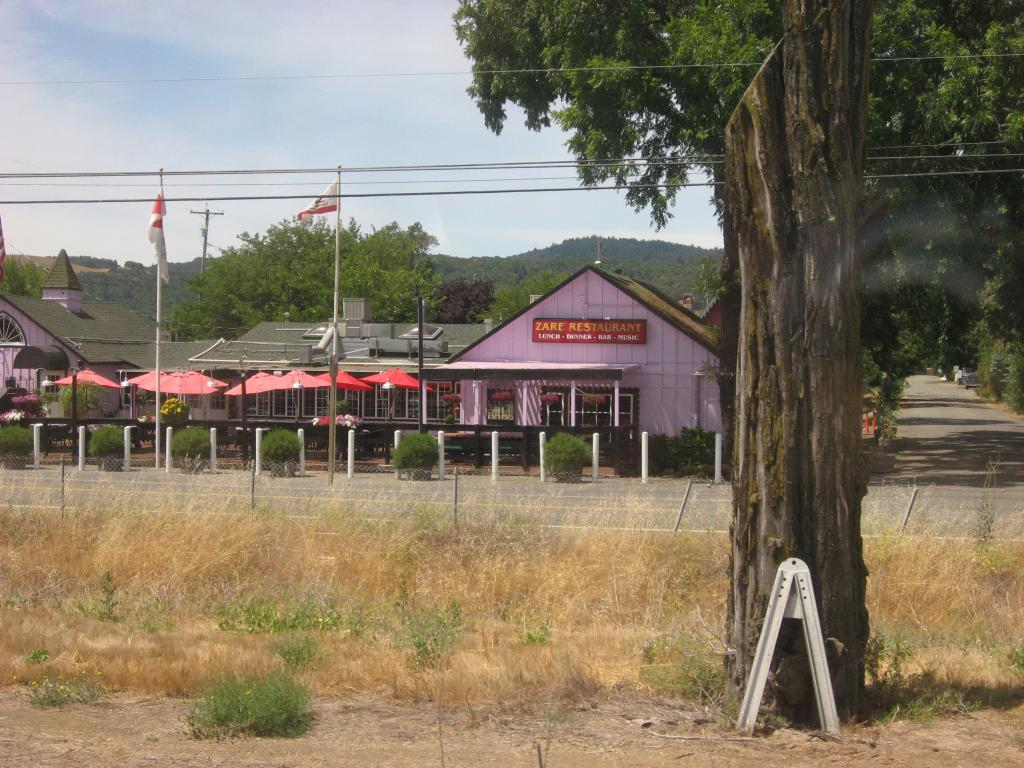What is placed near the tree trunk in the image? There is an object placed near the tree trunk in the image, but the specific object is not mentioned in the facts. What type of vegetation can be seen in the image? There is grass visible in the image, and there are also trees in the image. What architectural feature is present in the image? There is a fence in the image. What type of structures can be seen in the image? There are houses in the image. What is the condition of the sky in the background of the image? The sky is cloudy in the background of the image. Can you see a banana being peeled by a fireman in the image? There is no banana or fireman present in the image. What type of heart-shaped object can be seen in the image? There is no heart-shaped object present in the image. 